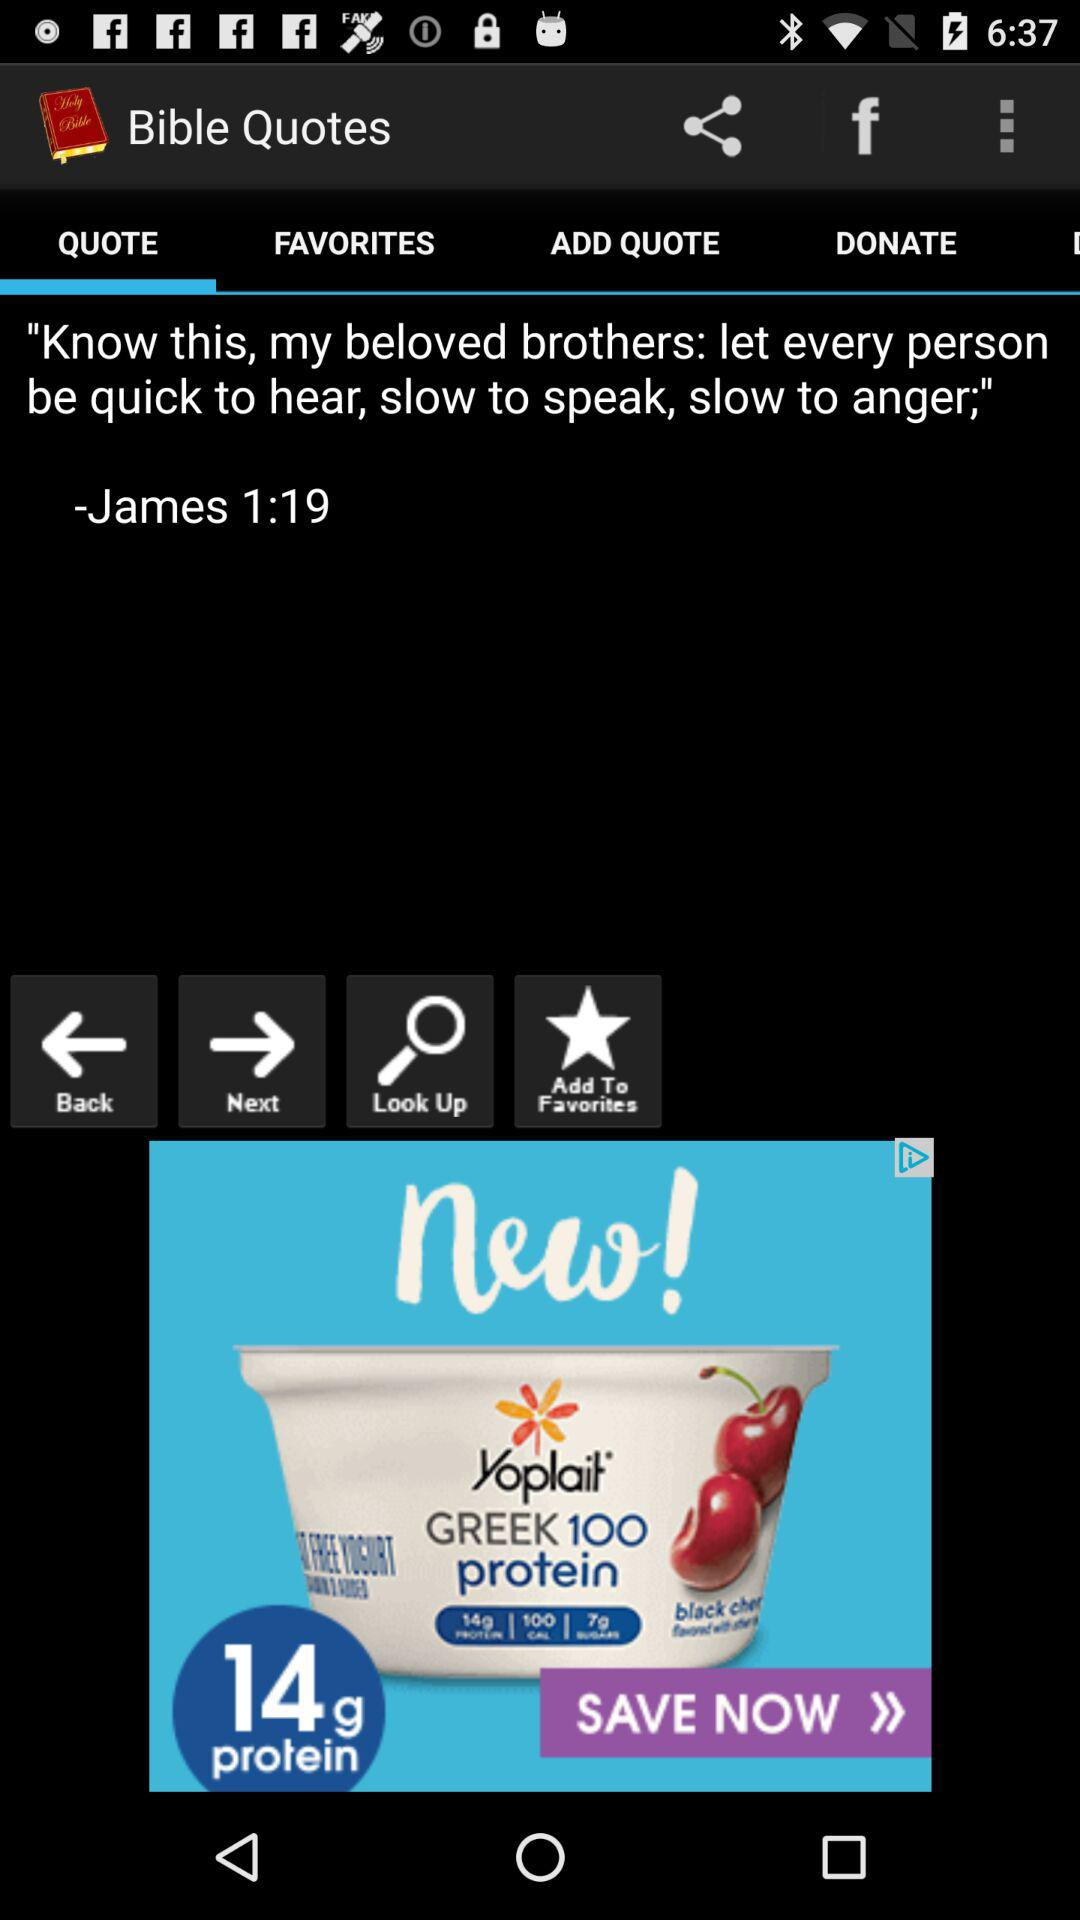Who wrote the quote, "Know this, my beloved brothers: let every person be quick to hear, slow to speak, slow to anger;"? The quote was written by James. 